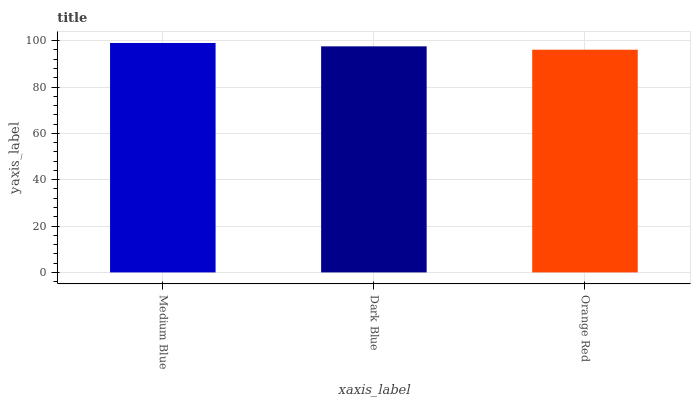Is Dark Blue the minimum?
Answer yes or no. No. Is Dark Blue the maximum?
Answer yes or no. No. Is Medium Blue greater than Dark Blue?
Answer yes or no. Yes. Is Dark Blue less than Medium Blue?
Answer yes or no. Yes. Is Dark Blue greater than Medium Blue?
Answer yes or no. No. Is Medium Blue less than Dark Blue?
Answer yes or no. No. Is Dark Blue the high median?
Answer yes or no. Yes. Is Dark Blue the low median?
Answer yes or no. Yes. Is Medium Blue the high median?
Answer yes or no. No. Is Medium Blue the low median?
Answer yes or no. No. 